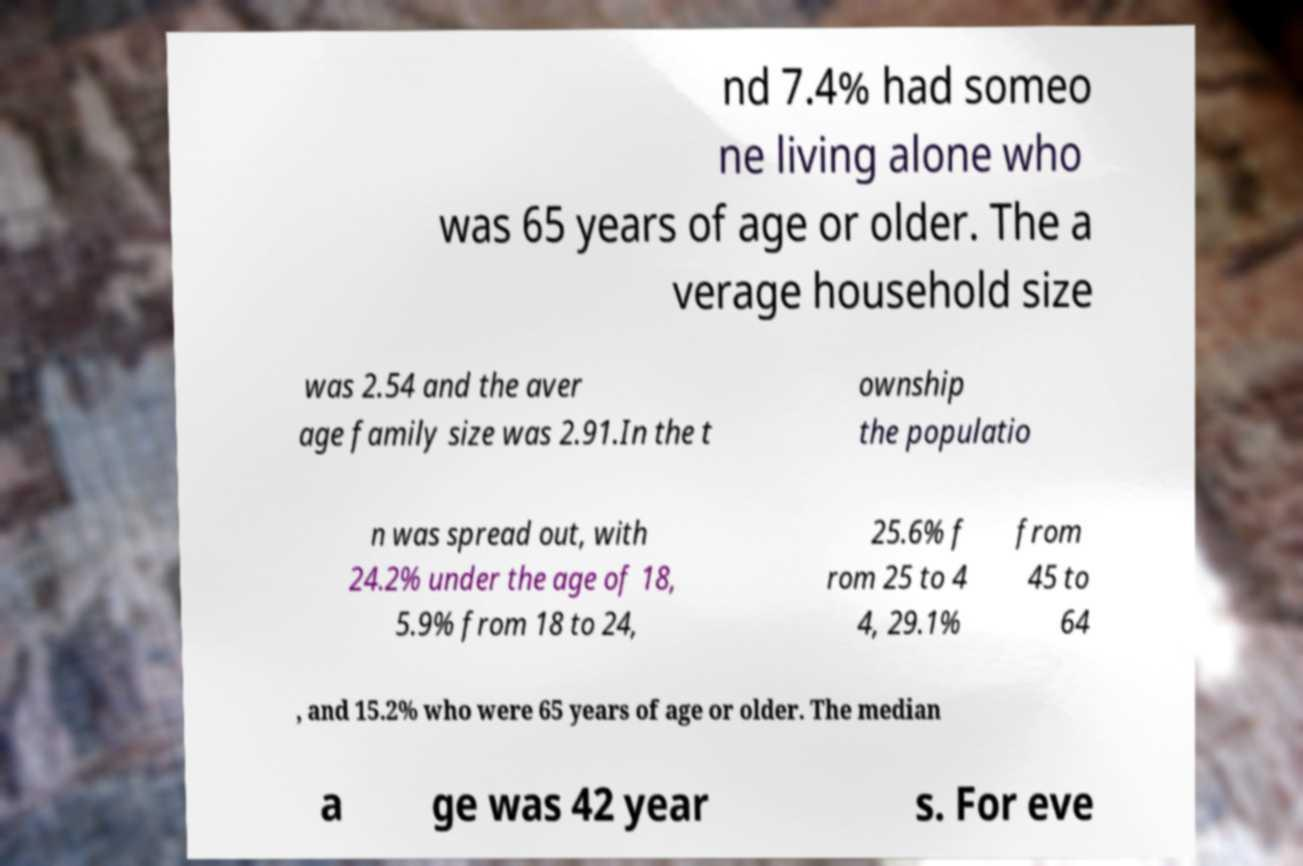There's text embedded in this image that I need extracted. Can you transcribe it verbatim? nd 7.4% had someo ne living alone who was 65 years of age or older. The a verage household size was 2.54 and the aver age family size was 2.91.In the t ownship the populatio n was spread out, with 24.2% under the age of 18, 5.9% from 18 to 24, 25.6% f rom 25 to 4 4, 29.1% from 45 to 64 , and 15.2% who were 65 years of age or older. The median a ge was 42 year s. For eve 